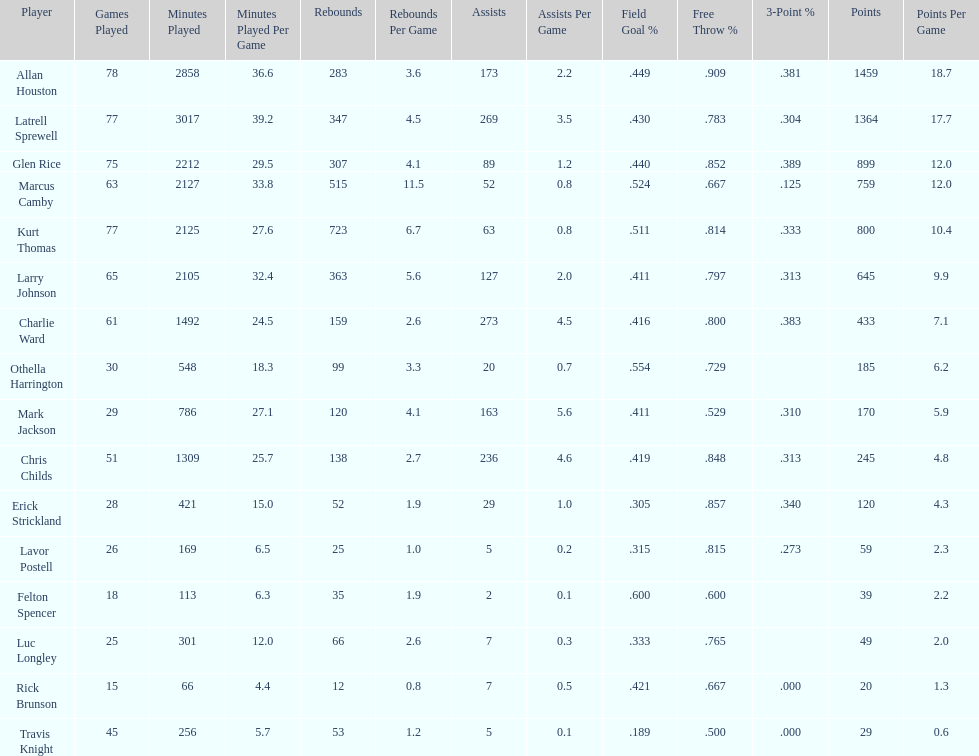How many total points were scored by players averaging over 4 assists per game> 848. 